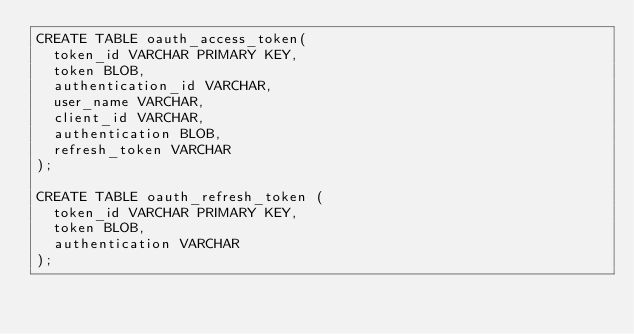Convert code to text. <code><loc_0><loc_0><loc_500><loc_500><_SQL_>CREATE TABLE oauth_access_token(
	token_id VARCHAR PRIMARY KEY, 
	token BLOB, 
	authentication_id VARCHAR, 
	user_name VARCHAR, 
	client_id VARCHAR, 
	authentication BLOB, 
	refresh_token VARCHAR
);

CREATE TABLE oauth_refresh_token (
	token_id VARCHAR PRIMARY KEY,
	token BLOB,
	authentication VARCHAR
);</code> 